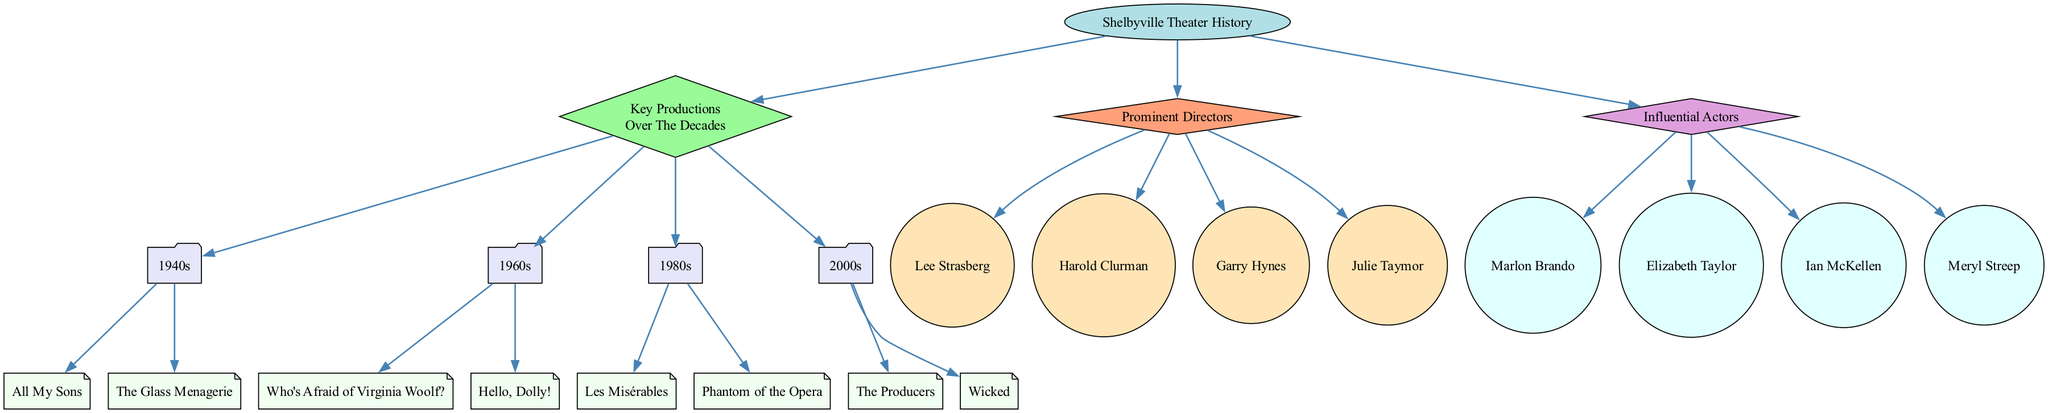What key productions were staged in the 1960s? The diagram indicates the key productions listed under the 1960s folder node. Specifically, those productions are "Who's Afraid of Virginia Woolf?" and "Hello, Dolly!"
Answer: Who's Afraid of Virginia Woolf?, Hello, Dolly! How many prominent directors are listed in the diagram? By counting the nodes that fall under the "Prominent Directors" category, we can see there are four names listed: Lee Strasberg, Harold Clurman, Garry Hynes, and Julie Taymor.
Answer: 4 Which influential actor is in the diagram? The inquiry asks for a specific name listed under the "Influential Actors." One actor shown is "Marlon Brando."
Answer: Marlon Brando What decade features "Les Misérables"? The diagram places "Les Misérables" under the 1980s folder node. This means it is one of the key productions for that specific decade.
Answer: 1980s Which director is connected to the "Prominent Directors" node? In tracing the edges from the "Prominent Directors" node, we see that it connects to directors like Lee Strasberg, Harold Clurman, Garry Hynes, and Julie Taymor. One of the names is "Garry Hynes."
Answer: Garry Hynes How many key productions are listed under the 1940s? The diagram reveals that there are two productions under the 1940s: "All My Sons" and "The Glass Menagerie." Thus, the count of productions is two.
Answer: 2 What is the relationship between "Influential Actors" and the productions listed? The diagram indicates that "Influential Actors" is a distinct node and is not directly connected to the key productions, illustrating that while they share a cultural context, they represent different aspects of theater history.
Answer: No direct relationship Name the influential actor that shares a node with Elizabeth Taylor. Since both Elizabeth Taylor and Ian McKellen are classified under the same "Influential Actors" node, they share the same category. One of the influential actors listed is "Ian McKellen."
Answer: Ian McKellen 